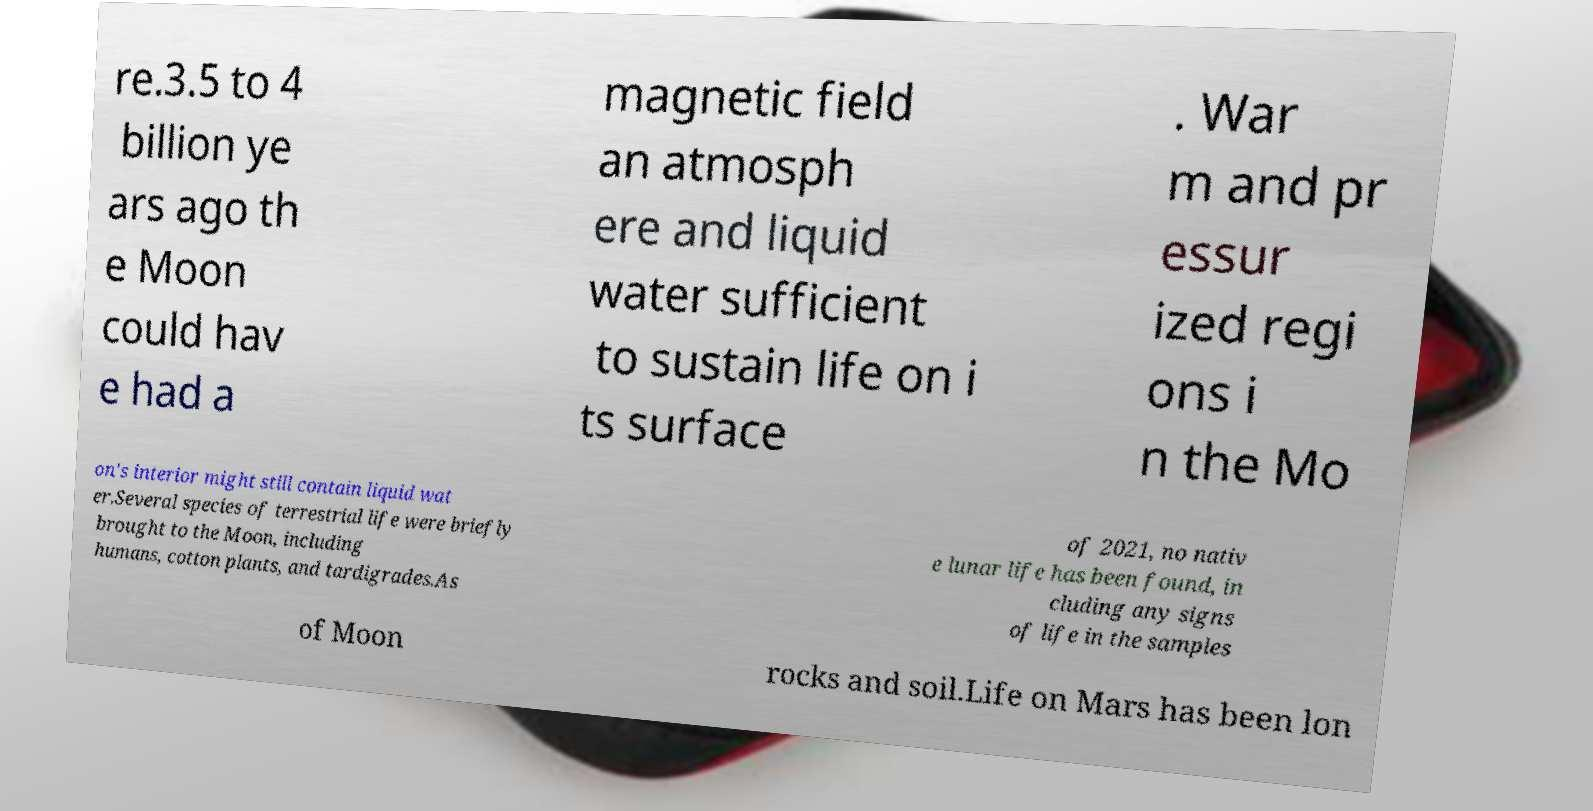Please identify and transcribe the text found in this image. re.3.5 to 4 billion ye ars ago th e Moon could hav e had a magnetic field an atmosph ere and liquid water sufficient to sustain life on i ts surface . War m and pr essur ized regi ons i n the Mo on's interior might still contain liquid wat er.Several species of terrestrial life were briefly brought to the Moon, including humans, cotton plants, and tardigrades.As of 2021, no nativ e lunar life has been found, in cluding any signs of life in the samples of Moon rocks and soil.Life on Mars has been lon 